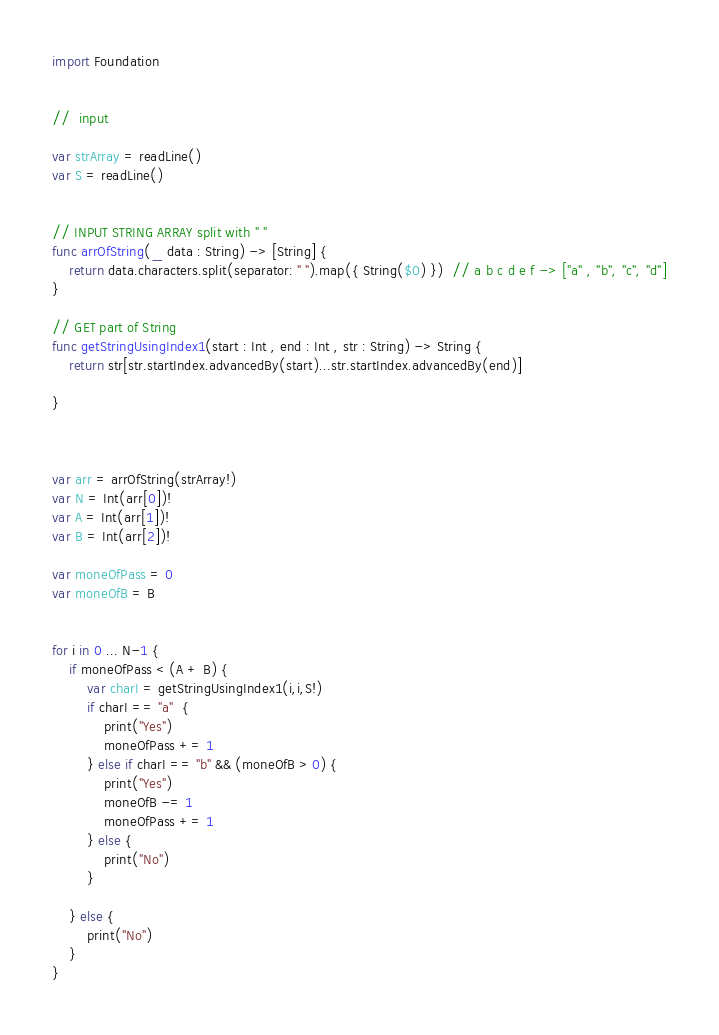<code> <loc_0><loc_0><loc_500><loc_500><_Swift_>import Foundation


//  input

var strArray = readLine()
var S = readLine()


// INPUT STRING ARRAY split with " "
func arrOfString(_ data : String) -> [String] {
    return data.characters.split(separator: " ").map({ String($0) })  // a b c d e f -> ["a" , "b", "c", "d"]
}

// GET part of String
func getStringUsingIndex1(start : Int , end : Int , str : String) -> String {
    return str[str.startIndex.advancedBy(start)...str.startIndex.advancedBy(end)]
    
}



var arr = arrOfString(strArray!)
var N = Int(arr[0])!
var A = Int(arr[1])!
var B = Int(arr[2])!

var moneOfPass = 0
var moneOfB = B


for i in 0 ... N-1 {
    if moneOfPass < (A + B) {
        var charI = getStringUsingIndex1(i,i,S!)
        if charI == "a"  {
            print("Yes")
            moneOfPass += 1
        } else if charI == "b" && (moneOfB > 0) {
            print("Yes")
            moneOfB -= 1
            moneOfPass += 1
        } else {
            print("No")
        }
        
    } else {
        print("No")
    }
}</code> 